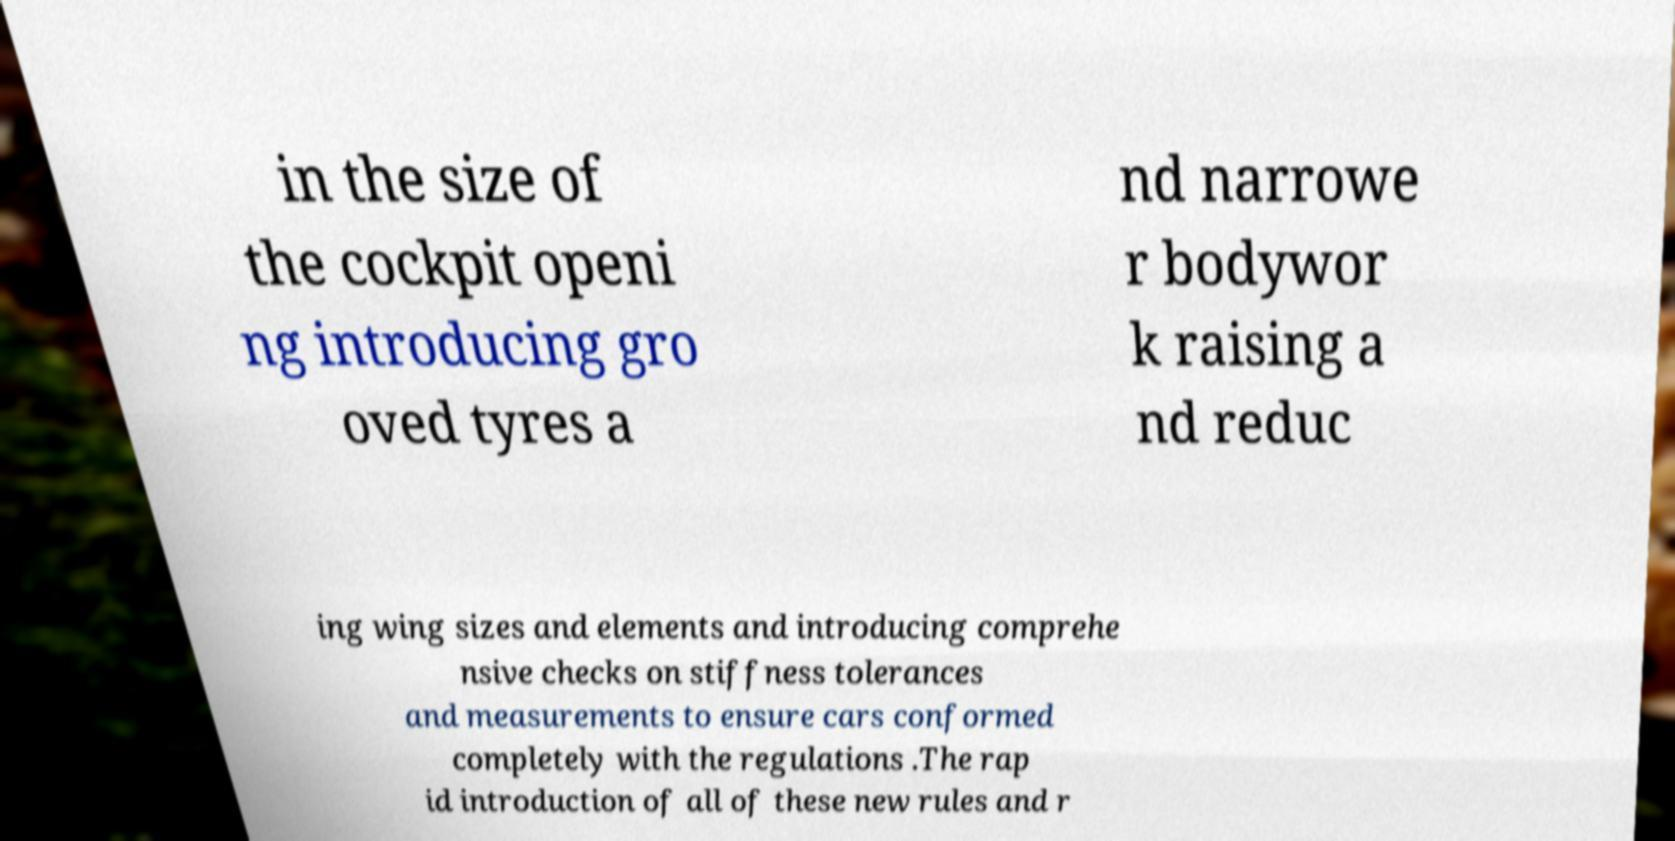What messages or text are displayed in this image? I need them in a readable, typed format. in the size of the cockpit openi ng introducing gro oved tyres a nd narrowe r bodywor k raising a nd reduc ing wing sizes and elements and introducing comprehe nsive checks on stiffness tolerances and measurements to ensure cars conformed completely with the regulations .The rap id introduction of all of these new rules and r 